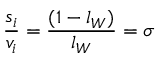Convert formula to latex. <formula><loc_0><loc_0><loc_500><loc_500>{ \frac { s _ { i } } { v _ { i } } } = { \frac { ( 1 - l _ { W } ) } { l _ { W } } } = \sigma</formula> 